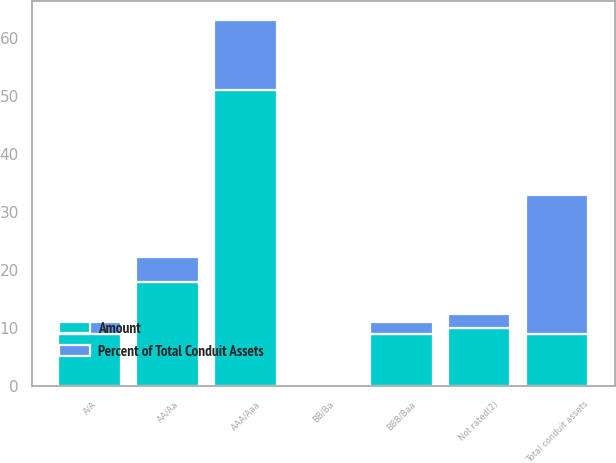<chart> <loc_0><loc_0><loc_500><loc_500><stacked_bar_chart><ecel><fcel>AAA/Aaa<fcel>AA/Aa<fcel>A/A<fcel>BBB/Baa<fcel>BB/Ba<fcel>Not rated(2)<fcel>Total conduit assets<nl><fcel>Percent of Total Conduit Assets<fcel>12.16<fcel>4.36<fcel>2.1<fcel>2.05<fcel>0.11<fcel>2.47<fcel>23.89<nl><fcel>Amount<fcel>51<fcel>18<fcel>9<fcel>9<fcel>0<fcel>10<fcel>9<nl></chart> 